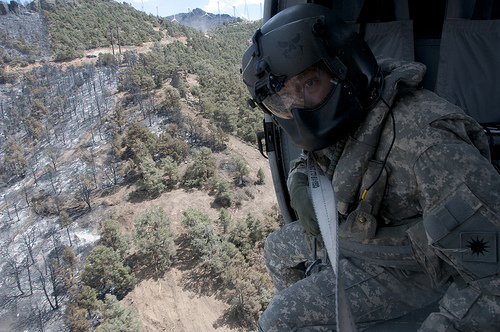<image>
Can you confirm if the sky is behind the mountain? Yes. From this viewpoint, the sky is positioned behind the mountain, with the mountain partially or fully occluding the sky. 